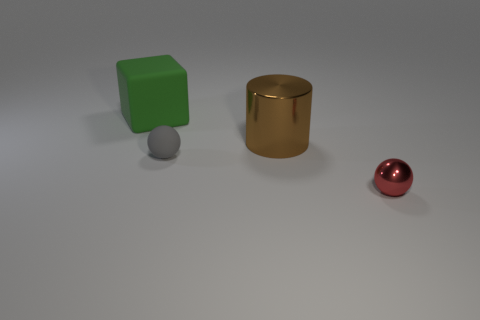Is there any other thing of the same color as the big block?
Your response must be concise. No. The other object that is the same material as the gray object is what size?
Make the answer very short. Large. What material is the brown cylinder?
Ensure brevity in your answer.  Metal. What number of green matte cubes have the same size as the gray matte thing?
Your answer should be very brief. 0. Is there another thing of the same shape as the small red thing?
Keep it short and to the point. Yes. There is a thing that is the same size as the cube; what color is it?
Your answer should be compact. Brown. The tiny ball in front of the rubber object in front of the large green matte thing is what color?
Your response must be concise. Red. There is a object that is in front of the gray rubber sphere; does it have the same color as the tiny rubber object?
Provide a succinct answer. No. There is a small thing that is behind the shiny thing that is in front of the large thing right of the green block; what is its shape?
Make the answer very short. Sphere. What number of large brown things are right of the big thing behind the brown metal object?
Your answer should be compact. 1. 